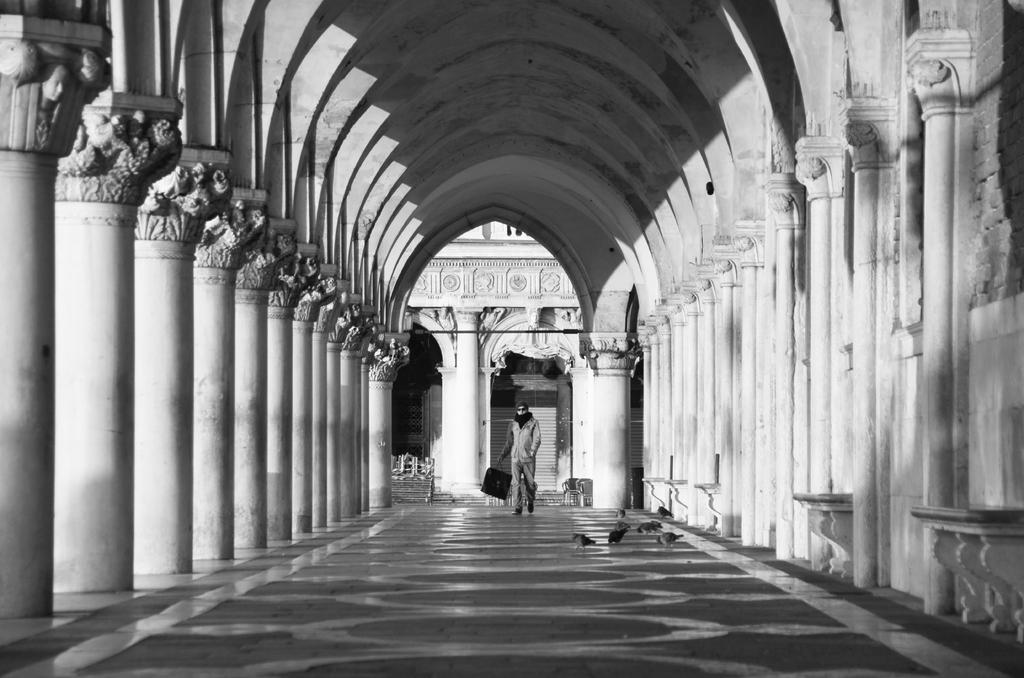What architectural features can be seen in the image? There are pillars and a rooftop visible in the image. What is present on the ground in the image? There are flocks of birds on the floor in the image. What can be used to enter or exit a room in the image? There is a door in the image. What type of artwork is present in the image? There are sculptures in the image. What is the person in the image doing? A person is walking in the image. What type of location might the image depict? The image may have been taken in a palace. How many trucks are parked on the rooftop in the image? There are no trucks present in the image; it features pillars, a rooftop, birds, a door, sculptures, and a person walking. What is the limit of the kettle in the image? There is no kettle present in the image. 